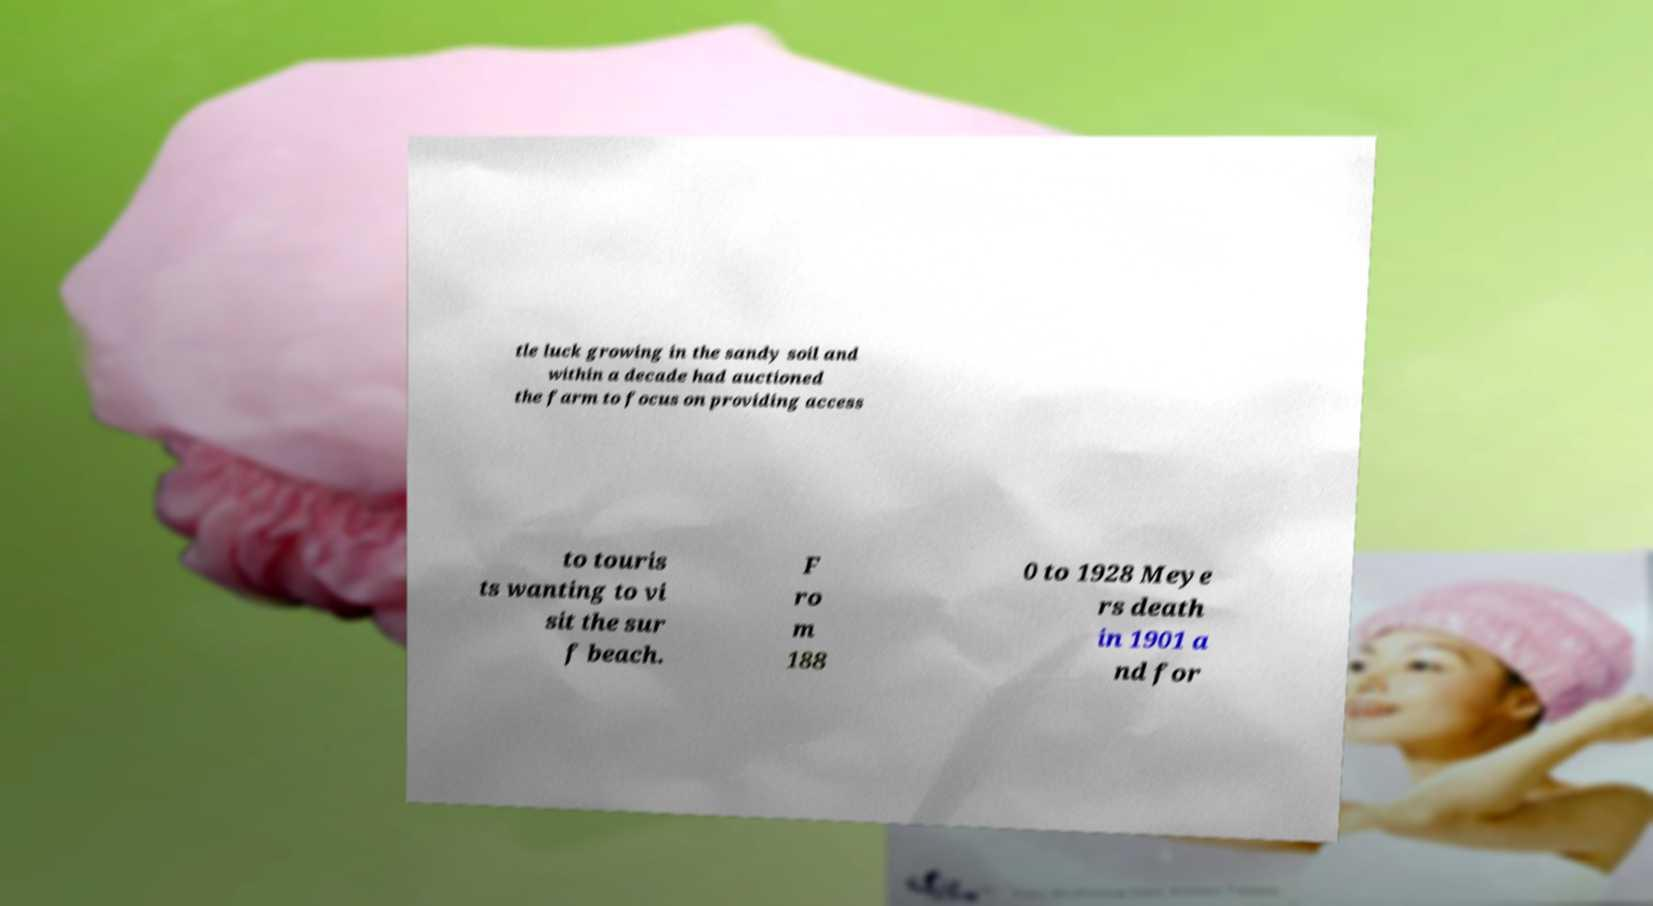I need the written content from this picture converted into text. Can you do that? tle luck growing in the sandy soil and within a decade had auctioned the farm to focus on providing access to touris ts wanting to vi sit the sur f beach. F ro m 188 0 to 1928 Meye rs death in 1901 a nd for 